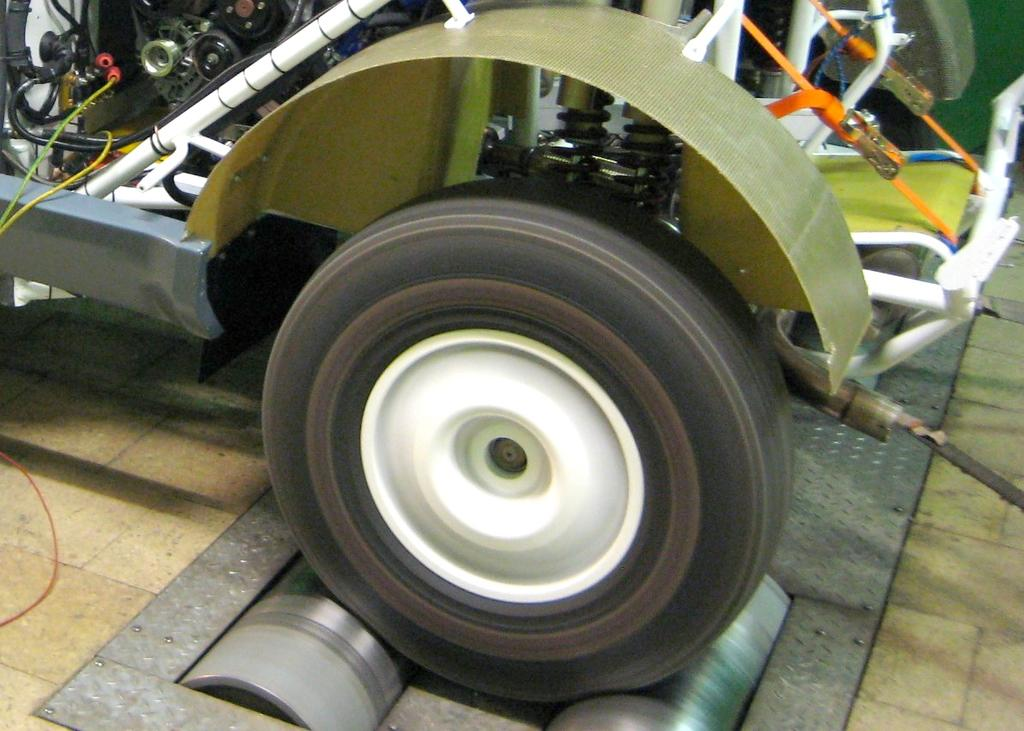What is the main subject of the image? There is a vehicle in the image. How many trees are visible on the calculator in the image? There are no trees or calculators present in the image; it features a vehicle. 